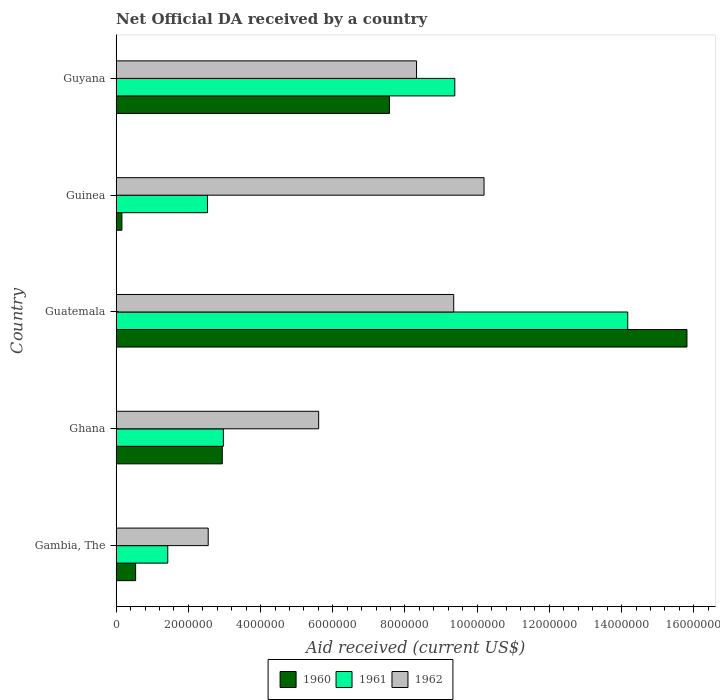Are the number of bars per tick equal to the number of legend labels?
Offer a terse response. Yes. How many bars are there on the 1st tick from the top?
Your answer should be very brief. 3. What is the label of the 2nd group of bars from the top?
Provide a succinct answer. Guinea. In how many cases, is the number of bars for a given country not equal to the number of legend labels?
Provide a succinct answer. 0. What is the net official development assistance aid received in 1962 in Gambia, The?
Your answer should be compact. 2.55e+06. Across all countries, what is the maximum net official development assistance aid received in 1960?
Offer a very short reply. 1.58e+07. Across all countries, what is the minimum net official development assistance aid received in 1960?
Keep it short and to the point. 1.60e+05. In which country was the net official development assistance aid received in 1961 maximum?
Make the answer very short. Guatemala. In which country was the net official development assistance aid received in 1962 minimum?
Keep it short and to the point. Gambia, The. What is the total net official development assistance aid received in 1960 in the graph?
Offer a terse response. 2.70e+07. What is the difference between the net official development assistance aid received in 1961 in Ghana and that in Guyana?
Your answer should be compact. -6.41e+06. What is the difference between the net official development assistance aid received in 1960 in Guyana and the net official development assistance aid received in 1962 in Ghana?
Offer a very short reply. 1.96e+06. What is the average net official development assistance aid received in 1960 per country?
Keep it short and to the point. 5.40e+06. What is the difference between the net official development assistance aid received in 1960 and net official development assistance aid received in 1961 in Gambia, The?
Your answer should be compact. -8.90e+05. In how many countries, is the net official development assistance aid received in 1961 greater than 9200000 US$?
Give a very brief answer. 2. What is the ratio of the net official development assistance aid received in 1962 in Gambia, The to that in Guyana?
Provide a short and direct response. 0.31. Is the difference between the net official development assistance aid received in 1960 in Ghana and Guatemala greater than the difference between the net official development assistance aid received in 1961 in Ghana and Guatemala?
Make the answer very short. No. What is the difference between the highest and the second highest net official development assistance aid received in 1961?
Your answer should be very brief. 4.79e+06. What is the difference between the highest and the lowest net official development assistance aid received in 1961?
Give a very brief answer. 1.27e+07. What does the 2nd bar from the top in Guinea represents?
Keep it short and to the point. 1961. What does the 2nd bar from the bottom in Guinea represents?
Offer a terse response. 1961. How many bars are there?
Provide a succinct answer. 15. How many countries are there in the graph?
Your response must be concise. 5. What is the difference between two consecutive major ticks on the X-axis?
Provide a succinct answer. 2.00e+06. Are the values on the major ticks of X-axis written in scientific E-notation?
Keep it short and to the point. No. Does the graph contain grids?
Your response must be concise. No. Where does the legend appear in the graph?
Give a very brief answer. Bottom center. How many legend labels are there?
Your answer should be compact. 3. What is the title of the graph?
Provide a short and direct response. Net Official DA received by a country. What is the label or title of the X-axis?
Your response must be concise. Aid received (current US$). What is the label or title of the Y-axis?
Offer a very short reply. Country. What is the Aid received (current US$) in 1960 in Gambia, The?
Make the answer very short. 5.40e+05. What is the Aid received (current US$) in 1961 in Gambia, The?
Make the answer very short. 1.43e+06. What is the Aid received (current US$) of 1962 in Gambia, The?
Provide a succinct answer. 2.55e+06. What is the Aid received (current US$) of 1960 in Ghana?
Your response must be concise. 2.94e+06. What is the Aid received (current US$) of 1961 in Ghana?
Provide a succinct answer. 2.97e+06. What is the Aid received (current US$) of 1962 in Ghana?
Keep it short and to the point. 5.61e+06. What is the Aid received (current US$) of 1960 in Guatemala?
Ensure brevity in your answer.  1.58e+07. What is the Aid received (current US$) in 1961 in Guatemala?
Give a very brief answer. 1.42e+07. What is the Aid received (current US$) of 1962 in Guatemala?
Your response must be concise. 9.35e+06. What is the Aid received (current US$) of 1961 in Guinea?
Make the answer very short. 2.53e+06. What is the Aid received (current US$) in 1962 in Guinea?
Your answer should be very brief. 1.02e+07. What is the Aid received (current US$) in 1960 in Guyana?
Provide a succinct answer. 7.57e+06. What is the Aid received (current US$) of 1961 in Guyana?
Your response must be concise. 9.38e+06. What is the Aid received (current US$) of 1962 in Guyana?
Provide a succinct answer. 8.32e+06. Across all countries, what is the maximum Aid received (current US$) of 1960?
Keep it short and to the point. 1.58e+07. Across all countries, what is the maximum Aid received (current US$) of 1961?
Offer a very short reply. 1.42e+07. Across all countries, what is the maximum Aid received (current US$) in 1962?
Make the answer very short. 1.02e+07. Across all countries, what is the minimum Aid received (current US$) of 1960?
Ensure brevity in your answer.  1.60e+05. Across all countries, what is the minimum Aid received (current US$) of 1961?
Provide a short and direct response. 1.43e+06. Across all countries, what is the minimum Aid received (current US$) of 1962?
Provide a succinct answer. 2.55e+06. What is the total Aid received (current US$) in 1960 in the graph?
Give a very brief answer. 2.70e+07. What is the total Aid received (current US$) of 1961 in the graph?
Your answer should be compact. 3.05e+07. What is the total Aid received (current US$) of 1962 in the graph?
Your answer should be compact. 3.60e+07. What is the difference between the Aid received (current US$) in 1960 in Gambia, The and that in Ghana?
Offer a terse response. -2.40e+06. What is the difference between the Aid received (current US$) in 1961 in Gambia, The and that in Ghana?
Your response must be concise. -1.54e+06. What is the difference between the Aid received (current US$) of 1962 in Gambia, The and that in Ghana?
Your response must be concise. -3.06e+06. What is the difference between the Aid received (current US$) of 1960 in Gambia, The and that in Guatemala?
Provide a succinct answer. -1.53e+07. What is the difference between the Aid received (current US$) of 1961 in Gambia, The and that in Guatemala?
Make the answer very short. -1.27e+07. What is the difference between the Aid received (current US$) in 1962 in Gambia, The and that in Guatemala?
Make the answer very short. -6.80e+06. What is the difference between the Aid received (current US$) of 1961 in Gambia, The and that in Guinea?
Offer a terse response. -1.10e+06. What is the difference between the Aid received (current US$) of 1962 in Gambia, The and that in Guinea?
Keep it short and to the point. -7.64e+06. What is the difference between the Aid received (current US$) in 1960 in Gambia, The and that in Guyana?
Your answer should be compact. -7.03e+06. What is the difference between the Aid received (current US$) of 1961 in Gambia, The and that in Guyana?
Make the answer very short. -7.95e+06. What is the difference between the Aid received (current US$) of 1962 in Gambia, The and that in Guyana?
Keep it short and to the point. -5.77e+06. What is the difference between the Aid received (current US$) of 1960 in Ghana and that in Guatemala?
Offer a terse response. -1.29e+07. What is the difference between the Aid received (current US$) of 1961 in Ghana and that in Guatemala?
Offer a very short reply. -1.12e+07. What is the difference between the Aid received (current US$) in 1962 in Ghana and that in Guatemala?
Keep it short and to the point. -3.74e+06. What is the difference between the Aid received (current US$) in 1960 in Ghana and that in Guinea?
Your answer should be compact. 2.78e+06. What is the difference between the Aid received (current US$) in 1962 in Ghana and that in Guinea?
Provide a succinct answer. -4.58e+06. What is the difference between the Aid received (current US$) of 1960 in Ghana and that in Guyana?
Make the answer very short. -4.63e+06. What is the difference between the Aid received (current US$) of 1961 in Ghana and that in Guyana?
Give a very brief answer. -6.41e+06. What is the difference between the Aid received (current US$) of 1962 in Ghana and that in Guyana?
Your answer should be very brief. -2.71e+06. What is the difference between the Aid received (current US$) of 1960 in Guatemala and that in Guinea?
Make the answer very short. 1.56e+07. What is the difference between the Aid received (current US$) in 1961 in Guatemala and that in Guinea?
Your answer should be very brief. 1.16e+07. What is the difference between the Aid received (current US$) in 1962 in Guatemala and that in Guinea?
Provide a succinct answer. -8.40e+05. What is the difference between the Aid received (current US$) in 1960 in Guatemala and that in Guyana?
Your answer should be compact. 8.24e+06. What is the difference between the Aid received (current US$) in 1961 in Guatemala and that in Guyana?
Keep it short and to the point. 4.79e+06. What is the difference between the Aid received (current US$) in 1962 in Guatemala and that in Guyana?
Give a very brief answer. 1.03e+06. What is the difference between the Aid received (current US$) in 1960 in Guinea and that in Guyana?
Keep it short and to the point. -7.41e+06. What is the difference between the Aid received (current US$) in 1961 in Guinea and that in Guyana?
Provide a short and direct response. -6.85e+06. What is the difference between the Aid received (current US$) of 1962 in Guinea and that in Guyana?
Provide a succinct answer. 1.87e+06. What is the difference between the Aid received (current US$) in 1960 in Gambia, The and the Aid received (current US$) in 1961 in Ghana?
Your answer should be very brief. -2.43e+06. What is the difference between the Aid received (current US$) in 1960 in Gambia, The and the Aid received (current US$) in 1962 in Ghana?
Keep it short and to the point. -5.07e+06. What is the difference between the Aid received (current US$) of 1961 in Gambia, The and the Aid received (current US$) of 1962 in Ghana?
Offer a terse response. -4.18e+06. What is the difference between the Aid received (current US$) in 1960 in Gambia, The and the Aid received (current US$) in 1961 in Guatemala?
Ensure brevity in your answer.  -1.36e+07. What is the difference between the Aid received (current US$) of 1960 in Gambia, The and the Aid received (current US$) of 1962 in Guatemala?
Provide a succinct answer. -8.81e+06. What is the difference between the Aid received (current US$) of 1961 in Gambia, The and the Aid received (current US$) of 1962 in Guatemala?
Make the answer very short. -7.92e+06. What is the difference between the Aid received (current US$) of 1960 in Gambia, The and the Aid received (current US$) of 1961 in Guinea?
Offer a terse response. -1.99e+06. What is the difference between the Aid received (current US$) of 1960 in Gambia, The and the Aid received (current US$) of 1962 in Guinea?
Your response must be concise. -9.65e+06. What is the difference between the Aid received (current US$) of 1961 in Gambia, The and the Aid received (current US$) of 1962 in Guinea?
Provide a short and direct response. -8.76e+06. What is the difference between the Aid received (current US$) in 1960 in Gambia, The and the Aid received (current US$) in 1961 in Guyana?
Offer a terse response. -8.84e+06. What is the difference between the Aid received (current US$) of 1960 in Gambia, The and the Aid received (current US$) of 1962 in Guyana?
Offer a very short reply. -7.78e+06. What is the difference between the Aid received (current US$) of 1961 in Gambia, The and the Aid received (current US$) of 1962 in Guyana?
Ensure brevity in your answer.  -6.89e+06. What is the difference between the Aid received (current US$) of 1960 in Ghana and the Aid received (current US$) of 1961 in Guatemala?
Provide a short and direct response. -1.12e+07. What is the difference between the Aid received (current US$) of 1960 in Ghana and the Aid received (current US$) of 1962 in Guatemala?
Your answer should be compact. -6.41e+06. What is the difference between the Aid received (current US$) in 1961 in Ghana and the Aid received (current US$) in 1962 in Guatemala?
Make the answer very short. -6.38e+06. What is the difference between the Aid received (current US$) of 1960 in Ghana and the Aid received (current US$) of 1961 in Guinea?
Provide a short and direct response. 4.10e+05. What is the difference between the Aid received (current US$) in 1960 in Ghana and the Aid received (current US$) in 1962 in Guinea?
Give a very brief answer. -7.25e+06. What is the difference between the Aid received (current US$) in 1961 in Ghana and the Aid received (current US$) in 1962 in Guinea?
Offer a very short reply. -7.22e+06. What is the difference between the Aid received (current US$) in 1960 in Ghana and the Aid received (current US$) in 1961 in Guyana?
Provide a succinct answer. -6.44e+06. What is the difference between the Aid received (current US$) in 1960 in Ghana and the Aid received (current US$) in 1962 in Guyana?
Your answer should be compact. -5.38e+06. What is the difference between the Aid received (current US$) of 1961 in Ghana and the Aid received (current US$) of 1962 in Guyana?
Provide a succinct answer. -5.35e+06. What is the difference between the Aid received (current US$) in 1960 in Guatemala and the Aid received (current US$) in 1961 in Guinea?
Your answer should be compact. 1.33e+07. What is the difference between the Aid received (current US$) of 1960 in Guatemala and the Aid received (current US$) of 1962 in Guinea?
Keep it short and to the point. 5.62e+06. What is the difference between the Aid received (current US$) of 1961 in Guatemala and the Aid received (current US$) of 1962 in Guinea?
Make the answer very short. 3.98e+06. What is the difference between the Aid received (current US$) of 1960 in Guatemala and the Aid received (current US$) of 1961 in Guyana?
Offer a very short reply. 6.43e+06. What is the difference between the Aid received (current US$) of 1960 in Guatemala and the Aid received (current US$) of 1962 in Guyana?
Your answer should be very brief. 7.49e+06. What is the difference between the Aid received (current US$) in 1961 in Guatemala and the Aid received (current US$) in 1962 in Guyana?
Offer a terse response. 5.85e+06. What is the difference between the Aid received (current US$) of 1960 in Guinea and the Aid received (current US$) of 1961 in Guyana?
Give a very brief answer. -9.22e+06. What is the difference between the Aid received (current US$) in 1960 in Guinea and the Aid received (current US$) in 1962 in Guyana?
Keep it short and to the point. -8.16e+06. What is the difference between the Aid received (current US$) of 1961 in Guinea and the Aid received (current US$) of 1962 in Guyana?
Keep it short and to the point. -5.79e+06. What is the average Aid received (current US$) in 1960 per country?
Make the answer very short. 5.40e+06. What is the average Aid received (current US$) in 1961 per country?
Your answer should be very brief. 6.10e+06. What is the average Aid received (current US$) of 1962 per country?
Make the answer very short. 7.20e+06. What is the difference between the Aid received (current US$) of 1960 and Aid received (current US$) of 1961 in Gambia, The?
Keep it short and to the point. -8.90e+05. What is the difference between the Aid received (current US$) in 1960 and Aid received (current US$) in 1962 in Gambia, The?
Ensure brevity in your answer.  -2.01e+06. What is the difference between the Aid received (current US$) of 1961 and Aid received (current US$) of 1962 in Gambia, The?
Provide a short and direct response. -1.12e+06. What is the difference between the Aid received (current US$) of 1960 and Aid received (current US$) of 1962 in Ghana?
Give a very brief answer. -2.67e+06. What is the difference between the Aid received (current US$) of 1961 and Aid received (current US$) of 1962 in Ghana?
Provide a succinct answer. -2.64e+06. What is the difference between the Aid received (current US$) in 1960 and Aid received (current US$) in 1961 in Guatemala?
Your answer should be very brief. 1.64e+06. What is the difference between the Aid received (current US$) in 1960 and Aid received (current US$) in 1962 in Guatemala?
Your response must be concise. 6.46e+06. What is the difference between the Aid received (current US$) of 1961 and Aid received (current US$) of 1962 in Guatemala?
Offer a terse response. 4.82e+06. What is the difference between the Aid received (current US$) in 1960 and Aid received (current US$) in 1961 in Guinea?
Give a very brief answer. -2.37e+06. What is the difference between the Aid received (current US$) of 1960 and Aid received (current US$) of 1962 in Guinea?
Offer a terse response. -1.00e+07. What is the difference between the Aid received (current US$) of 1961 and Aid received (current US$) of 1962 in Guinea?
Your response must be concise. -7.66e+06. What is the difference between the Aid received (current US$) of 1960 and Aid received (current US$) of 1961 in Guyana?
Offer a terse response. -1.81e+06. What is the difference between the Aid received (current US$) in 1960 and Aid received (current US$) in 1962 in Guyana?
Your answer should be compact. -7.50e+05. What is the difference between the Aid received (current US$) of 1961 and Aid received (current US$) of 1962 in Guyana?
Your answer should be very brief. 1.06e+06. What is the ratio of the Aid received (current US$) of 1960 in Gambia, The to that in Ghana?
Make the answer very short. 0.18. What is the ratio of the Aid received (current US$) of 1961 in Gambia, The to that in Ghana?
Ensure brevity in your answer.  0.48. What is the ratio of the Aid received (current US$) in 1962 in Gambia, The to that in Ghana?
Offer a very short reply. 0.45. What is the ratio of the Aid received (current US$) in 1960 in Gambia, The to that in Guatemala?
Make the answer very short. 0.03. What is the ratio of the Aid received (current US$) in 1961 in Gambia, The to that in Guatemala?
Make the answer very short. 0.1. What is the ratio of the Aid received (current US$) of 1962 in Gambia, The to that in Guatemala?
Your answer should be very brief. 0.27. What is the ratio of the Aid received (current US$) of 1960 in Gambia, The to that in Guinea?
Your answer should be compact. 3.38. What is the ratio of the Aid received (current US$) of 1961 in Gambia, The to that in Guinea?
Make the answer very short. 0.57. What is the ratio of the Aid received (current US$) of 1962 in Gambia, The to that in Guinea?
Your response must be concise. 0.25. What is the ratio of the Aid received (current US$) in 1960 in Gambia, The to that in Guyana?
Provide a succinct answer. 0.07. What is the ratio of the Aid received (current US$) in 1961 in Gambia, The to that in Guyana?
Make the answer very short. 0.15. What is the ratio of the Aid received (current US$) of 1962 in Gambia, The to that in Guyana?
Offer a very short reply. 0.31. What is the ratio of the Aid received (current US$) in 1960 in Ghana to that in Guatemala?
Ensure brevity in your answer.  0.19. What is the ratio of the Aid received (current US$) of 1961 in Ghana to that in Guatemala?
Your answer should be very brief. 0.21. What is the ratio of the Aid received (current US$) of 1960 in Ghana to that in Guinea?
Give a very brief answer. 18.38. What is the ratio of the Aid received (current US$) of 1961 in Ghana to that in Guinea?
Your answer should be very brief. 1.17. What is the ratio of the Aid received (current US$) of 1962 in Ghana to that in Guinea?
Offer a terse response. 0.55. What is the ratio of the Aid received (current US$) of 1960 in Ghana to that in Guyana?
Ensure brevity in your answer.  0.39. What is the ratio of the Aid received (current US$) in 1961 in Ghana to that in Guyana?
Your response must be concise. 0.32. What is the ratio of the Aid received (current US$) in 1962 in Ghana to that in Guyana?
Your answer should be very brief. 0.67. What is the ratio of the Aid received (current US$) in 1960 in Guatemala to that in Guinea?
Make the answer very short. 98.81. What is the ratio of the Aid received (current US$) of 1961 in Guatemala to that in Guinea?
Offer a terse response. 5.6. What is the ratio of the Aid received (current US$) in 1962 in Guatemala to that in Guinea?
Ensure brevity in your answer.  0.92. What is the ratio of the Aid received (current US$) of 1960 in Guatemala to that in Guyana?
Keep it short and to the point. 2.09. What is the ratio of the Aid received (current US$) of 1961 in Guatemala to that in Guyana?
Provide a short and direct response. 1.51. What is the ratio of the Aid received (current US$) of 1962 in Guatemala to that in Guyana?
Your answer should be very brief. 1.12. What is the ratio of the Aid received (current US$) of 1960 in Guinea to that in Guyana?
Provide a short and direct response. 0.02. What is the ratio of the Aid received (current US$) of 1961 in Guinea to that in Guyana?
Offer a terse response. 0.27. What is the ratio of the Aid received (current US$) of 1962 in Guinea to that in Guyana?
Your answer should be very brief. 1.22. What is the difference between the highest and the second highest Aid received (current US$) of 1960?
Your response must be concise. 8.24e+06. What is the difference between the highest and the second highest Aid received (current US$) of 1961?
Make the answer very short. 4.79e+06. What is the difference between the highest and the second highest Aid received (current US$) of 1962?
Your answer should be compact. 8.40e+05. What is the difference between the highest and the lowest Aid received (current US$) of 1960?
Ensure brevity in your answer.  1.56e+07. What is the difference between the highest and the lowest Aid received (current US$) of 1961?
Make the answer very short. 1.27e+07. What is the difference between the highest and the lowest Aid received (current US$) of 1962?
Your answer should be compact. 7.64e+06. 